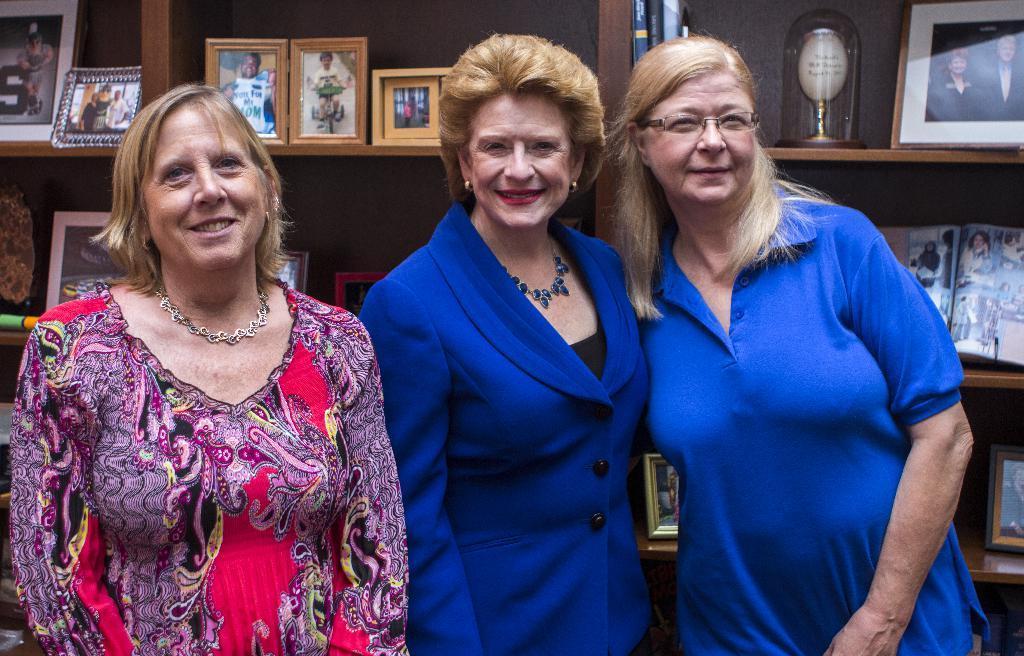How would you summarize this image in a sentence or two? In front of the picture, we see three women are standing. They are smiling and they are posing for the photo. Behind them, we see the racks in which many photo frames and a glass object are placed. 